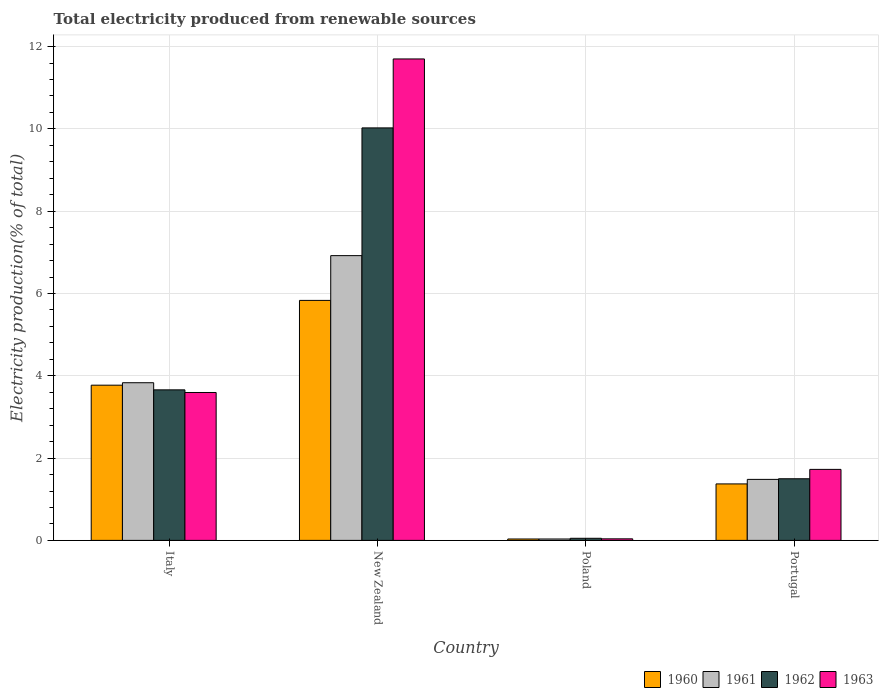How many groups of bars are there?
Keep it short and to the point. 4. Are the number of bars per tick equal to the number of legend labels?
Give a very brief answer. Yes. Are the number of bars on each tick of the X-axis equal?
Provide a succinct answer. Yes. What is the label of the 2nd group of bars from the left?
Give a very brief answer. New Zealand. What is the total electricity produced in 1960 in New Zealand?
Give a very brief answer. 5.83. Across all countries, what is the maximum total electricity produced in 1961?
Your response must be concise. 6.92. Across all countries, what is the minimum total electricity produced in 1963?
Your response must be concise. 0.04. In which country was the total electricity produced in 1960 maximum?
Your answer should be compact. New Zealand. What is the total total electricity produced in 1963 in the graph?
Offer a terse response. 17.06. What is the difference between the total electricity produced in 1960 in Italy and that in New Zealand?
Give a very brief answer. -2.06. What is the difference between the total electricity produced in 1961 in New Zealand and the total electricity produced in 1962 in Italy?
Offer a terse response. 3.26. What is the average total electricity produced in 1960 per country?
Your response must be concise. 2.75. What is the difference between the total electricity produced of/in 1962 and total electricity produced of/in 1960 in Italy?
Ensure brevity in your answer.  -0.11. In how many countries, is the total electricity produced in 1960 greater than 11.2 %?
Your response must be concise. 0. What is the ratio of the total electricity produced in 1962 in New Zealand to that in Poland?
Ensure brevity in your answer.  196.95. Is the total electricity produced in 1961 in Italy less than that in Portugal?
Offer a very short reply. No. What is the difference between the highest and the second highest total electricity produced in 1962?
Ensure brevity in your answer.  -8.53. What is the difference between the highest and the lowest total electricity produced in 1963?
Give a very brief answer. 11.66. In how many countries, is the total electricity produced in 1961 greater than the average total electricity produced in 1961 taken over all countries?
Offer a terse response. 2. Is it the case that in every country, the sum of the total electricity produced in 1960 and total electricity produced in 1963 is greater than the sum of total electricity produced in 1961 and total electricity produced in 1962?
Keep it short and to the point. No. What does the 1st bar from the left in Portugal represents?
Offer a terse response. 1960. What does the 3rd bar from the right in New Zealand represents?
Provide a succinct answer. 1961. Is it the case that in every country, the sum of the total electricity produced in 1963 and total electricity produced in 1960 is greater than the total electricity produced in 1962?
Keep it short and to the point. Yes. How many countries are there in the graph?
Provide a short and direct response. 4. What is the difference between two consecutive major ticks on the Y-axis?
Give a very brief answer. 2. Does the graph contain grids?
Give a very brief answer. Yes. Where does the legend appear in the graph?
Keep it short and to the point. Bottom right. What is the title of the graph?
Offer a terse response. Total electricity produced from renewable sources. What is the label or title of the X-axis?
Offer a terse response. Country. What is the Electricity production(% of total) of 1960 in Italy?
Provide a short and direct response. 3.77. What is the Electricity production(% of total) of 1961 in Italy?
Your answer should be compact. 3.83. What is the Electricity production(% of total) of 1962 in Italy?
Keep it short and to the point. 3.66. What is the Electricity production(% of total) of 1963 in Italy?
Provide a succinct answer. 3.59. What is the Electricity production(% of total) in 1960 in New Zealand?
Offer a terse response. 5.83. What is the Electricity production(% of total) of 1961 in New Zealand?
Provide a succinct answer. 6.92. What is the Electricity production(% of total) in 1962 in New Zealand?
Make the answer very short. 10.02. What is the Electricity production(% of total) in 1963 in New Zealand?
Your answer should be very brief. 11.7. What is the Electricity production(% of total) in 1960 in Poland?
Provide a short and direct response. 0.03. What is the Electricity production(% of total) in 1961 in Poland?
Your response must be concise. 0.03. What is the Electricity production(% of total) of 1962 in Poland?
Your answer should be very brief. 0.05. What is the Electricity production(% of total) in 1963 in Poland?
Keep it short and to the point. 0.04. What is the Electricity production(% of total) in 1960 in Portugal?
Ensure brevity in your answer.  1.37. What is the Electricity production(% of total) in 1961 in Portugal?
Make the answer very short. 1.48. What is the Electricity production(% of total) in 1962 in Portugal?
Make the answer very short. 1.5. What is the Electricity production(% of total) in 1963 in Portugal?
Provide a succinct answer. 1.73. Across all countries, what is the maximum Electricity production(% of total) of 1960?
Make the answer very short. 5.83. Across all countries, what is the maximum Electricity production(% of total) in 1961?
Keep it short and to the point. 6.92. Across all countries, what is the maximum Electricity production(% of total) of 1962?
Your answer should be compact. 10.02. Across all countries, what is the maximum Electricity production(% of total) in 1963?
Your answer should be compact. 11.7. Across all countries, what is the minimum Electricity production(% of total) of 1960?
Keep it short and to the point. 0.03. Across all countries, what is the minimum Electricity production(% of total) in 1961?
Provide a short and direct response. 0.03. Across all countries, what is the minimum Electricity production(% of total) of 1962?
Give a very brief answer. 0.05. Across all countries, what is the minimum Electricity production(% of total) in 1963?
Offer a terse response. 0.04. What is the total Electricity production(% of total) in 1960 in the graph?
Make the answer very short. 11.01. What is the total Electricity production(% of total) in 1961 in the graph?
Your answer should be compact. 12.27. What is the total Electricity production(% of total) in 1962 in the graph?
Ensure brevity in your answer.  15.23. What is the total Electricity production(% of total) in 1963 in the graph?
Give a very brief answer. 17.06. What is the difference between the Electricity production(% of total) of 1960 in Italy and that in New Zealand?
Give a very brief answer. -2.06. What is the difference between the Electricity production(% of total) in 1961 in Italy and that in New Zealand?
Your response must be concise. -3.09. What is the difference between the Electricity production(% of total) in 1962 in Italy and that in New Zealand?
Offer a terse response. -6.37. What is the difference between the Electricity production(% of total) of 1963 in Italy and that in New Zealand?
Ensure brevity in your answer.  -8.11. What is the difference between the Electricity production(% of total) of 1960 in Italy and that in Poland?
Ensure brevity in your answer.  3.74. What is the difference between the Electricity production(% of total) of 1961 in Italy and that in Poland?
Offer a very short reply. 3.8. What is the difference between the Electricity production(% of total) of 1962 in Italy and that in Poland?
Make the answer very short. 3.61. What is the difference between the Electricity production(% of total) in 1963 in Italy and that in Poland?
Offer a terse response. 3.56. What is the difference between the Electricity production(% of total) of 1960 in Italy and that in Portugal?
Offer a very short reply. 2.4. What is the difference between the Electricity production(% of total) of 1961 in Italy and that in Portugal?
Your answer should be very brief. 2.35. What is the difference between the Electricity production(% of total) in 1962 in Italy and that in Portugal?
Keep it short and to the point. 2.16. What is the difference between the Electricity production(% of total) of 1963 in Italy and that in Portugal?
Provide a short and direct response. 1.87. What is the difference between the Electricity production(% of total) in 1960 in New Zealand and that in Poland?
Make the answer very short. 5.8. What is the difference between the Electricity production(% of total) in 1961 in New Zealand and that in Poland?
Ensure brevity in your answer.  6.89. What is the difference between the Electricity production(% of total) of 1962 in New Zealand and that in Poland?
Provide a short and direct response. 9.97. What is the difference between the Electricity production(% of total) of 1963 in New Zealand and that in Poland?
Offer a terse response. 11.66. What is the difference between the Electricity production(% of total) in 1960 in New Zealand and that in Portugal?
Your answer should be very brief. 4.46. What is the difference between the Electricity production(% of total) of 1961 in New Zealand and that in Portugal?
Ensure brevity in your answer.  5.44. What is the difference between the Electricity production(% of total) of 1962 in New Zealand and that in Portugal?
Ensure brevity in your answer.  8.53. What is the difference between the Electricity production(% of total) of 1963 in New Zealand and that in Portugal?
Offer a very short reply. 9.97. What is the difference between the Electricity production(% of total) of 1960 in Poland and that in Portugal?
Give a very brief answer. -1.34. What is the difference between the Electricity production(% of total) of 1961 in Poland and that in Portugal?
Your response must be concise. -1.45. What is the difference between the Electricity production(% of total) in 1962 in Poland and that in Portugal?
Ensure brevity in your answer.  -1.45. What is the difference between the Electricity production(% of total) of 1963 in Poland and that in Portugal?
Offer a very short reply. -1.69. What is the difference between the Electricity production(% of total) of 1960 in Italy and the Electricity production(% of total) of 1961 in New Zealand?
Ensure brevity in your answer.  -3.15. What is the difference between the Electricity production(% of total) of 1960 in Italy and the Electricity production(% of total) of 1962 in New Zealand?
Provide a succinct answer. -6.25. What is the difference between the Electricity production(% of total) in 1960 in Italy and the Electricity production(% of total) in 1963 in New Zealand?
Provide a succinct answer. -7.93. What is the difference between the Electricity production(% of total) of 1961 in Italy and the Electricity production(% of total) of 1962 in New Zealand?
Keep it short and to the point. -6.19. What is the difference between the Electricity production(% of total) of 1961 in Italy and the Electricity production(% of total) of 1963 in New Zealand?
Offer a terse response. -7.87. What is the difference between the Electricity production(% of total) of 1962 in Italy and the Electricity production(% of total) of 1963 in New Zealand?
Keep it short and to the point. -8.04. What is the difference between the Electricity production(% of total) of 1960 in Italy and the Electricity production(% of total) of 1961 in Poland?
Keep it short and to the point. 3.74. What is the difference between the Electricity production(% of total) in 1960 in Italy and the Electricity production(% of total) in 1962 in Poland?
Your response must be concise. 3.72. What is the difference between the Electricity production(% of total) in 1960 in Italy and the Electricity production(% of total) in 1963 in Poland?
Give a very brief answer. 3.73. What is the difference between the Electricity production(% of total) of 1961 in Italy and the Electricity production(% of total) of 1962 in Poland?
Make the answer very short. 3.78. What is the difference between the Electricity production(% of total) of 1961 in Italy and the Electricity production(% of total) of 1963 in Poland?
Offer a very short reply. 3.79. What is the difference between the Electricity production(% of total) of 1962 in Italy and the Electricity production(% of total) of 1963 in Poland?
Make the answer very short. 3.62. What is the difference between the Electricity production(% of total) in 1960 in Italy and the Electricity production(% of total) in 1961 in Portugal?
Make the answer very short. 2.29. What is the difference between the Electricity production(% of total) of 1960 in Italy and the Electricity production(% of total) of 1962 in Portugal?
Offer a terse response. 2.27. What is the difference between the Electricity production(% of total) in 1960 in Italy and the Electricity production(% of total) in 1963 in Portugal?
Give a very brief answer. 2.05. What is the difference between the Electricity production(% of total) of 1961 in Italy and the Electricity production(% of total) of 1962 in Portugal?
Offer a terse response. 2.33. What is the difference between the Electricity production(% of total) in 1961 in Italy and the Electricity production(% of total) in 1963 in Portugal?
Provide a succinct answer. 2.11. What is the difference between the Electricity production(% of total) in 1962 in Italy and the Electricity production(% of total) in 1963 in Portugal?
Ensure brevity in your answer.  1.93. What is the difference between the Electricity production(% of total) of 1960 in New Zealand and the Electricity production(% of total) of 1961 in Poland?
Your response must be concise. 5.8. What is the difference between the Electricity production(% of total) of 1960 in New Zealand and the Electricity production(% of total) of 1962 in Poland?
Ensure brevity in your answer.  5.78. What is the difference between the Electricity production(% of total) of 1960 in New Zealand and the Electricity production(% of total) of 1963 in Poland?
Your answer should be compact. 5.79. What is the difference between the Electricity production(% of total) of 1961 in New Zealand and the Electricity production(% of total) of 1962 in Poland?
Keep it short and to the point. 6.87. What is the difference between the Electricity production(% of total) in 1961 in New Zealand and the Electricity production(% of total) in 1963 in Poland?
Your answer should be compact. 6.88. What is the difference between the Electricity production(% of total) in 1962 in New Zealand and the Electricity production(% of total) in 1963 in Poland?
Provide a short and direct response. 9.99. What is the difference between the Electricity production(% of total) of 1960 in New Zealand and the Electricity production(% of total) of 1961 in Portugal?
Give a very brief answer. 4.35. What is the difference between the Electricity production(% of total) of 1960 in New Zealand and the Electricity production(% of total) of 1962 in Portugal?
Your response must be concise. 4.33. What is the difference between the Electricity production(% of total) of 1960 in New Zealand and the Electricity production(% of total) of 1963 in Portugal?
Your answer should be compact. 4.11. What is the difference between the Electricity production(% of total) in 1961 in New Zealand and the Electricity production(% of total) in 1962 in Portugal?
Provide a short and direct response. 5.42. What is the difference between the Electricity production(% of total) in 1961 in New Zealand and the Electricity production(% of total) in 1963 in Portugal?
Your answer should be compact. 5.19. What is the difference between the Electricity production(% of total) in 1962 in New Zealand and the Electricity production(% of total) in 1963 in Portugal?
Offer a very short reply. 8.3. What is the difference between the Electricity production(% of total) of 1960 in Poland and the Electricity production(% of total) of 1961 in Portugal?
Your answer should be compact. -1.45. What is the difference between the Electricity production(% of total) of 1960 in Poland and the Electricity production(% of total) of 1962 in Portugal?
Offer a very short reply. -1.46. What is the difference between the Electricity production(% of total) in 1960 in Poland and the Electricity production(% of total) in 1963 in Portugal?
Give a very brief answer. -1.69. What is the difference between the Electricity production(% of total) of 1961 in Poland and the Electricity production(% of total) of 1962 in Portugal?
Give a very brief answer. -1.46. What is the difference between the Electricity production(% of total) in 1961 in Poland and the Electricity production(% of total) in 1963 in Portugal?
Provide a short and direct response. -1.69. What is the difference between the Electricity production(% of total) of 1962 in Poland and the Electricity production(% of total) of 1963 in Portugal?
Provide a short and direct response. -1.67. What is the average Electricity production(% of total) in 1960 per country?
Provide a short and direct response. 2.75. What is the average Electricity production(% of total) in 1961 per country?
Your response must be concise. 3.07. What is the average Electricity production(% of total) of 1962 per country?
Your response must be concise. 3.81. What is the average Electricity production(% of total) of 1963 per country?
Your response must be concise. 4.26. What is the difference between the Electricity production(% of total) in 1960 and Electricity production(% of total) in 1961 in Italy?
Give a very brief answer. -0.06. What is the difference between the Electricity production(% of total) in 1960 and Electricity production(% of total) in 1962 in Italy?
Ensure brevity in your answer.  0.11. What is the difference between the Electricity production(% of total) in 1960 and Electricity production(% of total) in 1963 in Italy?
Ensure brevity in your answer.  0.18. What is the difference between the Electricity production(% of total) in 1961 and Electricity production(% of total) in 1962 in Italy?
Make the answer very short. 0.17. What is the difference between the Electricity production(% of total) of 1961 and Electricity production(% of total) of 1963 in Italy?
Your answer should be very brief. 0.24. What is the difference between the Electricity production(% of total) of 1962 and Electricity production(% of total) of 1963 in Italy?
Make the answer very short. 0.06. What is the difference between the Electricity production(% of total) in 1960 and Electricity production(% of total) in 1961 in New Zealand?
Give a very brief answer. -1.09. What is the difference between the Electricity production(% of total) in 1960 and Electricity production(% of total) in 1962 in New Zealand?
Make the answer very short. -4.19. What is the difference between the Electricity production(% of total) of 1960 and Electricity production(% of total) of 1963 in New Zealand?
Your answer should be very brief. -5.87. What is the difference between the Electricity production(% of total) of 1961 and Electricity production(% of total) of 1962 in New Zealand?
Ensure brevity in your answer.  -3.1. What is the difference between the Electricity production(% of total) in 1961 and Electricity production(% of total) in 1963 in New Zealand?
Make the answer very short. -4.78. What is the difference between the Electricity production(% of total) of 1962 and Electricity production(% of total) of 1963 in New Zealand?
Your answer should be very brief. -1.68. What is the difference between the Electricity production(% of total) of 1960 and Electricity production(% of total) of 1961 in Poland?
Give a very brief answer. 0. What is the difference between the Electricity production(% of total) in 1960 and Electricity production(% of total) in 1962 in Poland?
Keep it short and to the point. -0.02. What is the difference between the Electricity production(% of total) in 1960 and Electricity production(% of total) in 1963 in Poland?
Keep it short and to the point. -0. What is the difference between the Electricity production(% of total) of 1961 and Electricity production(% of total) of 1962 in Poland?
Ensure brevity in your answer.  -0.02. What is the difference between the Electricity production(% of total) of 1961 and Electricity production(% of total) of 1963 in Poland?
Make the answer very short. -0. What is the difference between the Electricity production(% of total) of 1962 and Electricity production(% of total) of 1963 in Poland?
Make the answer very short. 0.01. What is the difference between the Electricity production(% of total) in 1960 and Electricity production(% of total) in 1961 in Portugal?
Offer a terse response. -0.11. What is the difference between the Electricity production(% of total) of 1960 and Electricity production(% of total) of 1962 in Portugal?
Keep it short and to the point. -0.13. What is the difference between the Electricity production(% of total) of 1960 and Electricity production(% of total) of 1963 in Portugal?
Your answer should be compact. -0.35. What is the difference between the Electricity production(% of total) in 1961 and Electricity production(% of total) in 1962 in Portugal?
Provide a succinct answer. -0.02. What is the difference between the Electricity production(% of total) in 1961 and Electricity production(% of total) in 1963 in Portugal?
Offer a terse response. -0.24. What is the difference between the Electricity production(% of total) of 1962 and Electricity production(% of total) of 1963 in Portugal?
Provide a short and direct response. -0.23. What is the ratio of the Electricity production(% of total) of 1960 in Italy to that in New Zealand?
Offer a terse response. 0.65. What is the ratio of the Electricity production(% of total) of 1961 in Italy to that in New Zealand?
Ensure brevity in your answer.  0.55. What is the ratio of the Electricity production(% of total) of 1962 in Italy to that in New Zealand?
Provide a short and direct response. 0.36. What is the ratio of the Electricity production(% of total) of 1963 in Italy to that in New Zealand?
Your answer should be compact. 0.31. What is the ratio of the Electricity production(% of total) of 1960 in Italy to that in Poland?
Make the answer very short. 110.45. What is the ratio of the Electricity production(% of total) of 1961 in Italy to that in Poland?
Keep it short and to the point. 112.3. What is the ratio of the Electricity production(% of total) of 1962 in Italy to that in Poland?
Ensure brevity in your answer.  71.88. What is the ratio of the Electricity production(% of total) of 1963 in Italy to that in Poland?
Your answer should be compact. 94.84. What is the ratio of the Electricity production(% of total) in 1960 in Italy to that in Portugal?
Your answer should be compact. 2.75. What is the ratio of the Electricity production(% of total) of 1961 in Italy to that in Portugal?
Provide a short and direct response. 2.58. What is the ratio of the Electricity production(% of total) of 1962 in Italy to that in Portugal?
Your answer should be compact. 2.44. What is the ratio of the Electricity production(% of total) of 1963 in Italy to that in Portugal?
Ensure brevity in your answer.  2.08. What is the ratio of the Electricity production(% of total) in 1960 in New Zealand to that in Poland?
Keep it short and to the point. 170.79. What is the ratio of the Electricity production(% of total) of 1961 in New Zealand to that in Poland?
Offer a very short reply. 202.83. What is the ratio of the Electricity production(% of total) in 1962 in New Zealand to that in Poland?
Your answer should be compact. 196.95. What is the ratio of the Electricity production(% of total) in 1963 in New Zealand to that in Poland?
Your answer should be very brief. 308.73. What is the ratio of the Electricity production(% of total) of 1960 in New Zealand to that in Portugal?
Your answer should be compact. 4.25. What is the ratio of the Electricity production(% of total) in 1961 in New Zealand to that in Portugal?
Your answer should be very brief. 4.67. What is the ratio of the Electricity production(% of total) in 1962 in New Zealand to that in Portugal?
Offer a very short reply. 6.69. What is the ratio of the Electricity production(% of total) in 1963 in New Zealand to that in Portugal?
Keep it short and to the point. 6.78. What is the ratio of the Electricity production(% of total) of 1960 in Poland to that in Portugal?
Your response must be concise. 0.02. What is the ratio of the Electricity production(% of total) of 1961 in Poland to that in Portugal?
Offer a very short reply. 0.02. What is the ratio of the Electricity production(% of total) in 1962 in Poland to that in Portugal?
Your response must be concise. 0.03. What is the ratio of the Electricity production(% of total) of 1963 in Poland to that in Portugal?
Ensure brevity in your answer.  0.02. What is the difference between the highest and the second highest Electricity production(% of total) of 1960?
Your answer should be very brief. 2.06. What is the difference between the highest and the second highest Electricity production(% of total) in 1961?
Provide a succinct answer. 3.09. What is the difference between the highest and the second highest Electricity production(% of total) in 1962?
Offer a very short reply. 6.37. What is the difference between the highest and the second highest Electricity production(% of total) of 1963?
Offer a terse response. 8.11. What is the difference between the highest and the lowest Electricity production(% of total) of 1960?
Offer a terse response. 5.8. What is the difference between the highest and the lowest Electricity production(% of total) in 1961?
Your response must be concise. 6.89. What is the difference between the highest and the lowest Electricity production(% of total) in 1962?
Ensure brevity in your answer.  9.97. What is the difference between the highest and the lowest Electricity production(% of total) of 1963?
Provide a short and direct response. 11.66. 